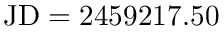<formula> <loc_0><loc_0><loc_500><loc_500>J D = 2 4 5 9 2 1 7 . 5 0</formula> 